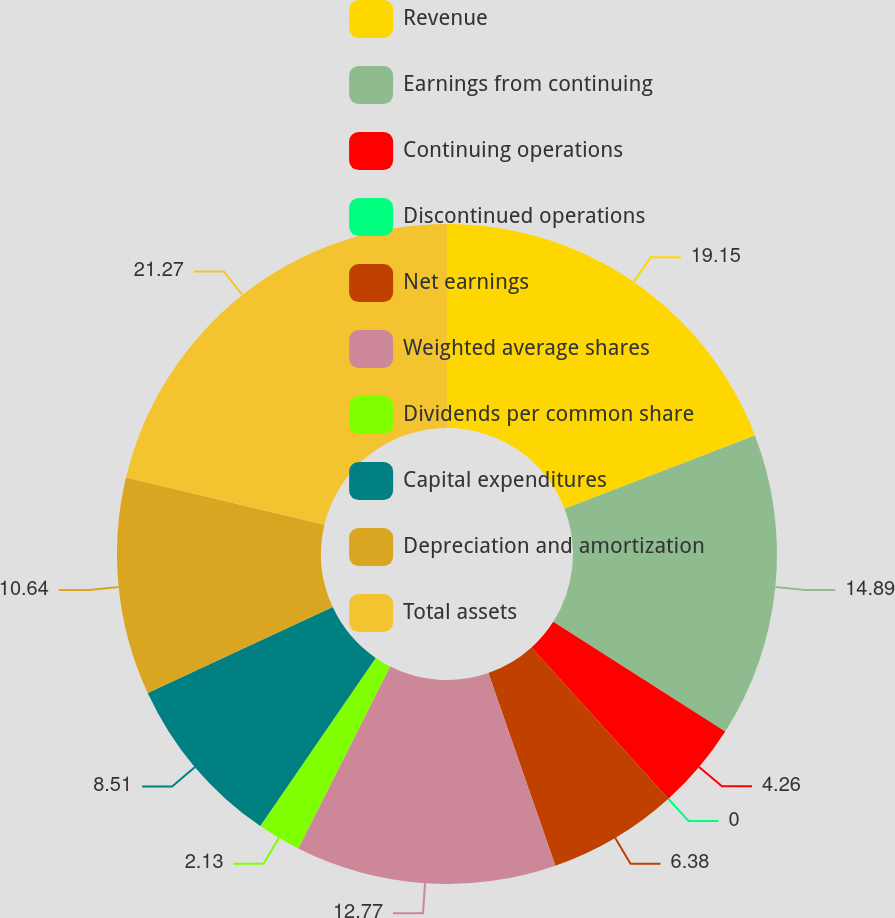Convert chart to OTSL. <chart><loc_0><loc_0><loc_500><loc_500><pie_chart><fcel>Revenue<fcel>Earnings from continuing<fcel>Continuing operations<fcel>Discontinued operations<fcel>Net earnings<fcel>Weighted average shares<fcel>Dividends per common share<fcel>Capital expenditures<fcel>Depreciation and amortization<fcel>Total assets<nl><fcel>19.15%<fcel>14.89%<fcel>4.26%<fcel>0.0%<fcel>6.38%<fcel>12.77%<fcel>2.13%<fcel>8.51%<fcel>10.64%<fcel>21.28%<nl></chart> 